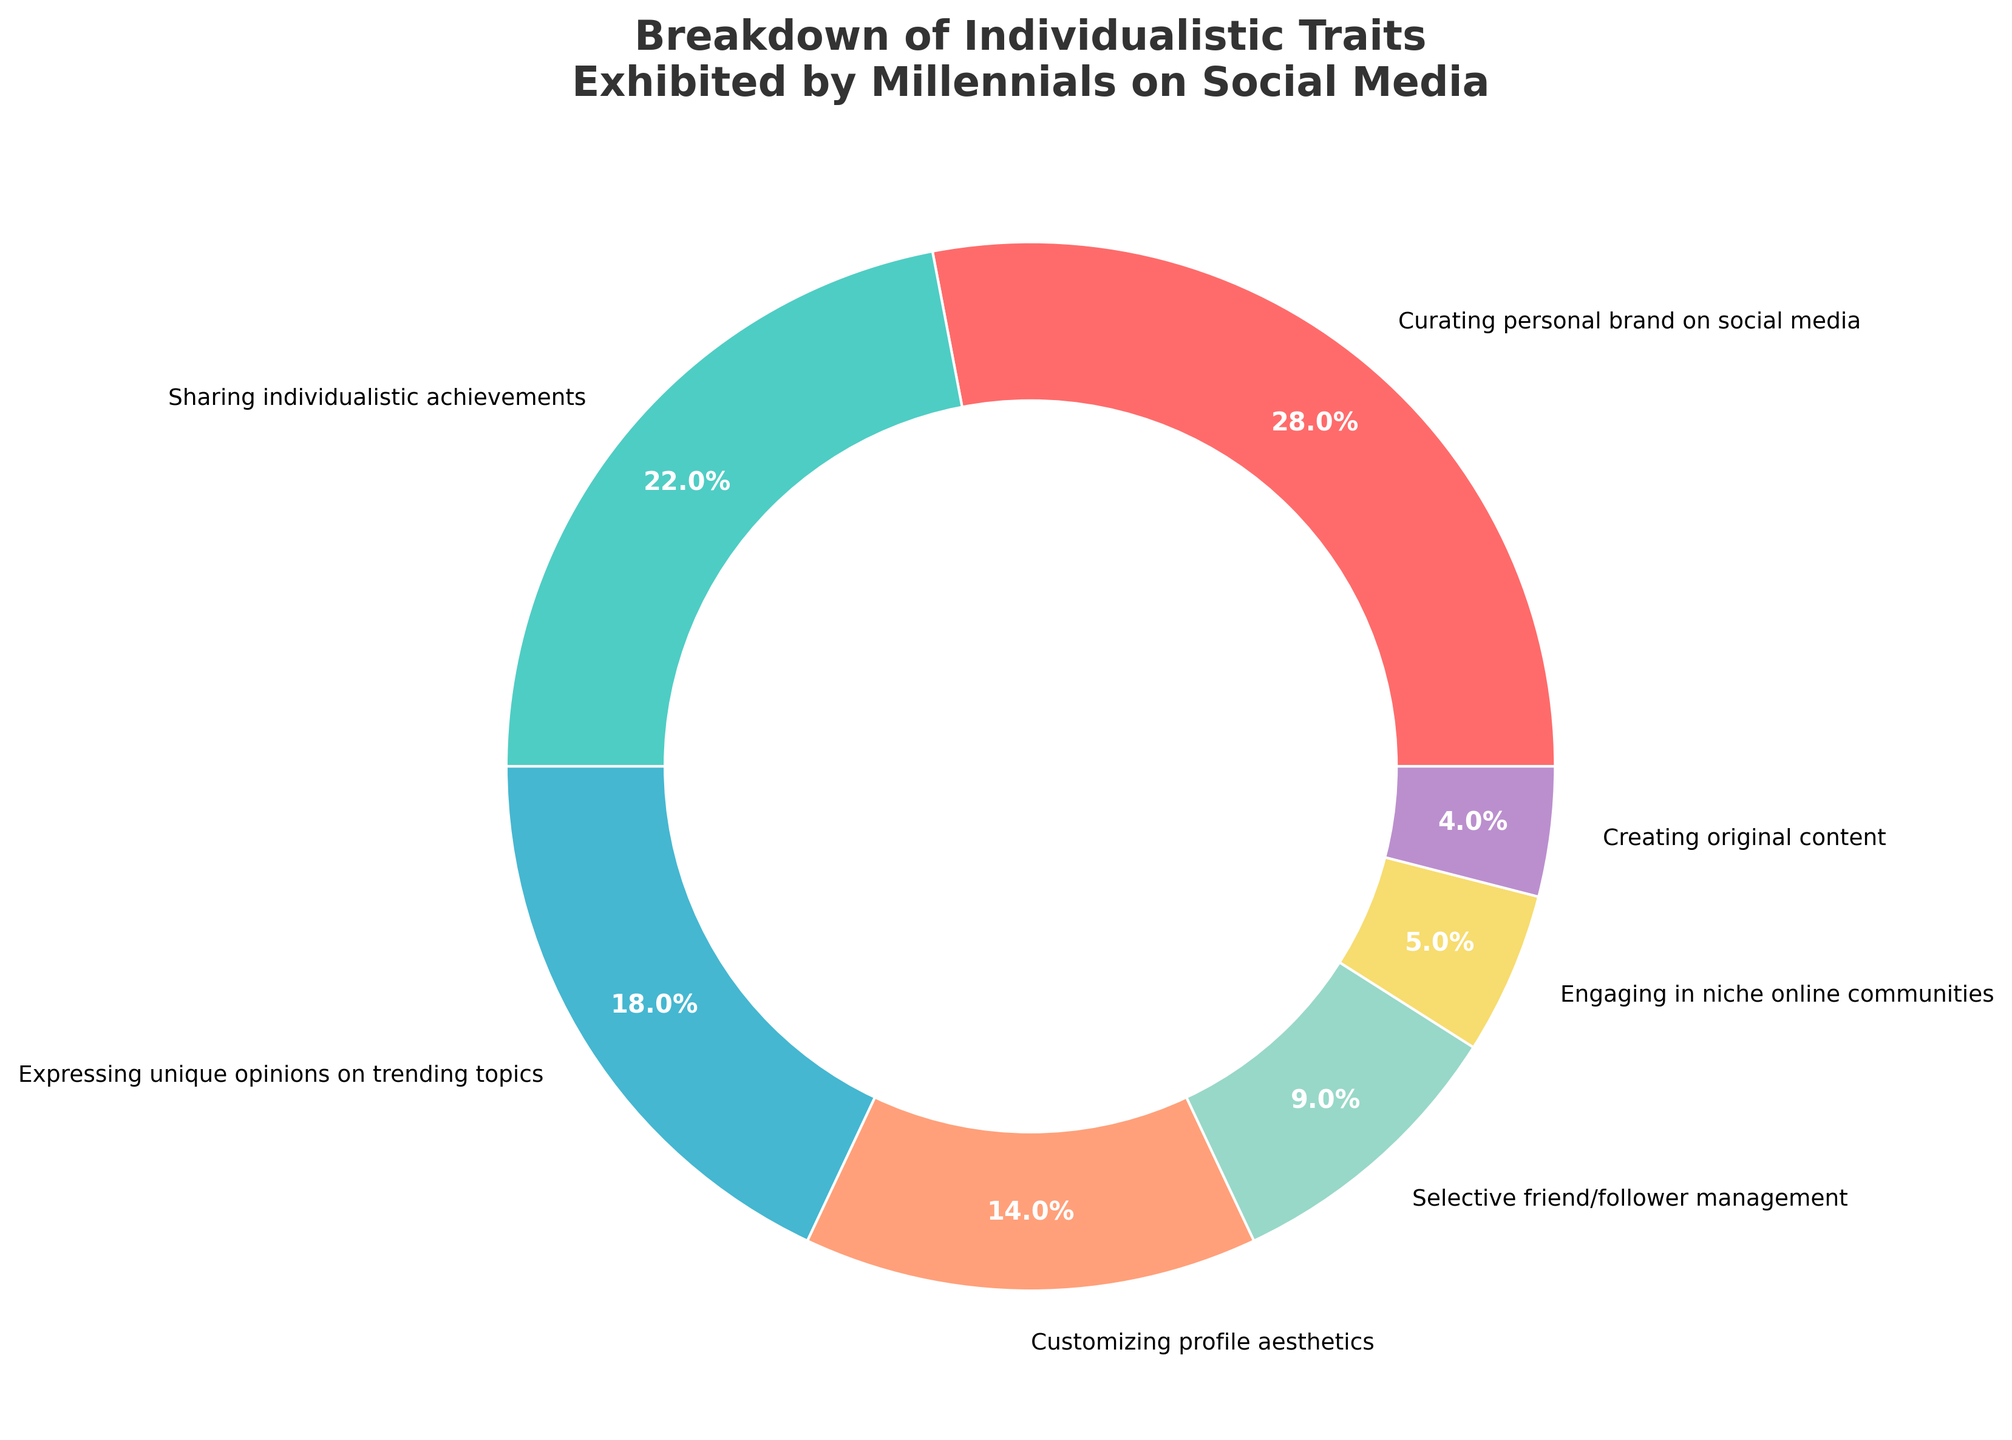Which trait has the highest percentage? The figure shows the percentages of various individualistic traits exhibited by millennials on social media. By locating the highest percentage section, we find "Curating personal brand on social media" at 28%.
Answer: Curating personal brand on social media Which traits together make up more than 40% of the chart? To determine this, we sum the percentages of the largest sections until we surpass 40%. "Curating personal brand on social media" (28%) and "Sharing individualistic achievements" (22%) together make up 50%.
Answer: Curating personal brand on social media, Sharing individualistic achievements Which trait has the smallest percentage? By observing the chart, the smallest section is identified as "Creating original content" with 4%.
Answer: Creating original content How much larger in percentage is "Curating personal brand on social media" compared to "Engaging in niche online communities"? Subtract the percentage of "Engaging in niche online communities" (5%) from "Curating personal brand on social media" (28%). The difference is 23%.
Answer: 23% What is the total percentage for traits related to managing social aspects (friends and communities)? Sum the percentages for "Selective friend/follower management" (9%) and "Engaging in niche online communities" (5%). The total is 14%.
Answer: 14% How do the percentages of "Expressing unique opinions on trending topics" and "Customizing profile aesthetics" compare? Compare the sections for these traits; “Expressing unique opinions on trending topics" is 18% and "Customizing profile aesthetics" is 14%. The former is 4% higher.
Answer: Expressing unique opinions on trending topics is 4% higher If we combine the percentages of the two smallest traits, how much do they contribute to the total? Sum the percentages of "Engaging in niche online communities" (5%) and "Creating original content" (4%). Together, they contribute 9%.
Answer: 9% Which trait is represented by the yellow section of the chart? By identifying the yellow section visually, it represents "Engaging in niche online communities."
Answer: Engaging in niche online communities What is the average percentage of the three largest traits? The three largest traits are "Curating personal brand on social media" (28%), "Sharing individualistic achievements" (22%), and "Expressing unique opinions on trending topics" (18%). Their average is (28 + 22 + 18)/3 = 22.67%
Answer: 22.67% 